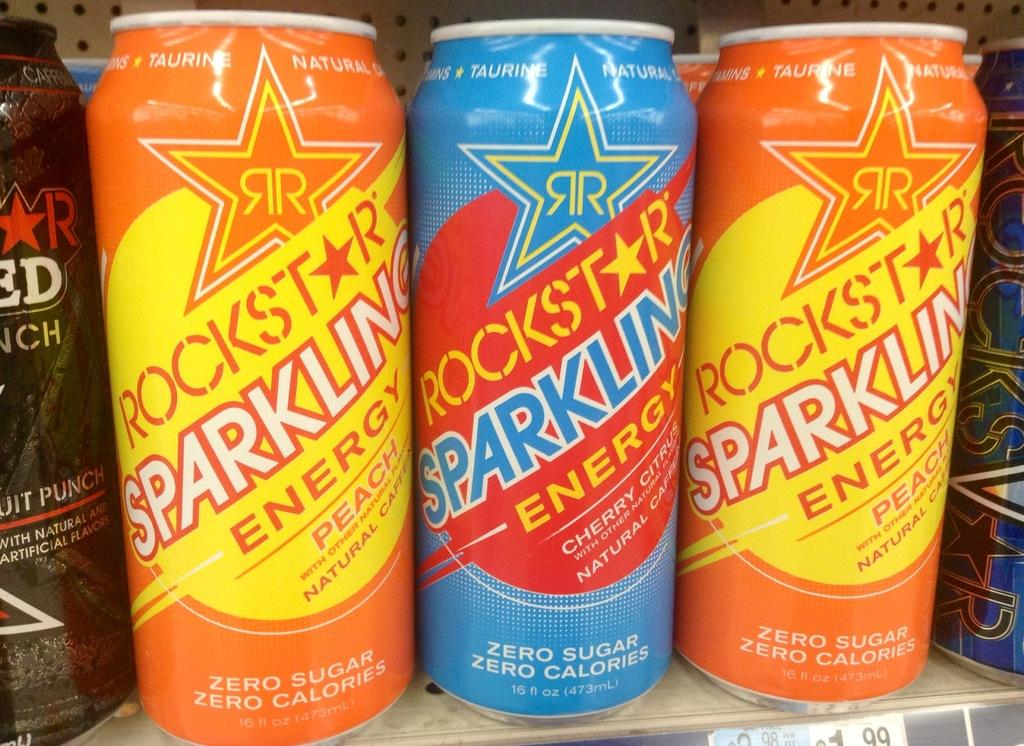<image>
Write a terse but informative summary of the picture. Three can of Rockstar Sparkling Energy are lined up on a shelf. 